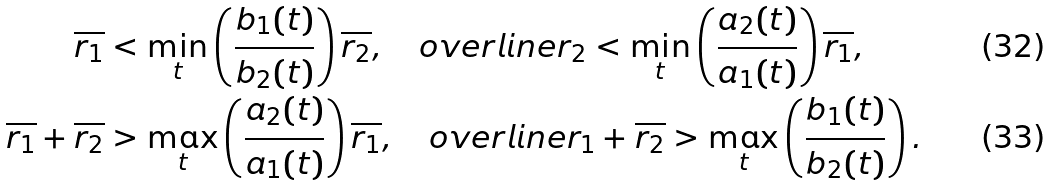<formula> <loc_0><loc_0><loc_500><loc_500>\overline { r _ { 1 } } & < \underset { t } { \min } \left ( \frac { b _ { 1 } ( t ) } { b _ { 2 } ( t ) } \right ) \overline { r _ { 2 } } , \quad o v e r l i n e { r _ { 2 } } < \underset { t } { \min } \left ( \frac { a _ { 2 } ( t ) } { a _ { 1 } ( t ) } \right ) \overline { r _ { 1 } } , \\ \overline { r _ { 1 } } + \overline { r _ { 2 } } & > \underset { t } { \max } \left ( \frac { a _ { 2 } ( t ) } { a _ { 1 } ( t ) } \right ) \overline { r _ { 1 } } , \quad o v e r l i n e { r _ { 1 } } + \overline { r _ { 2 } } > \underset { t } { \max } \left ( \frac { b _ { 1 } ( t ) } { b _ { 2 } ( t ) } \right ) .</formula> 